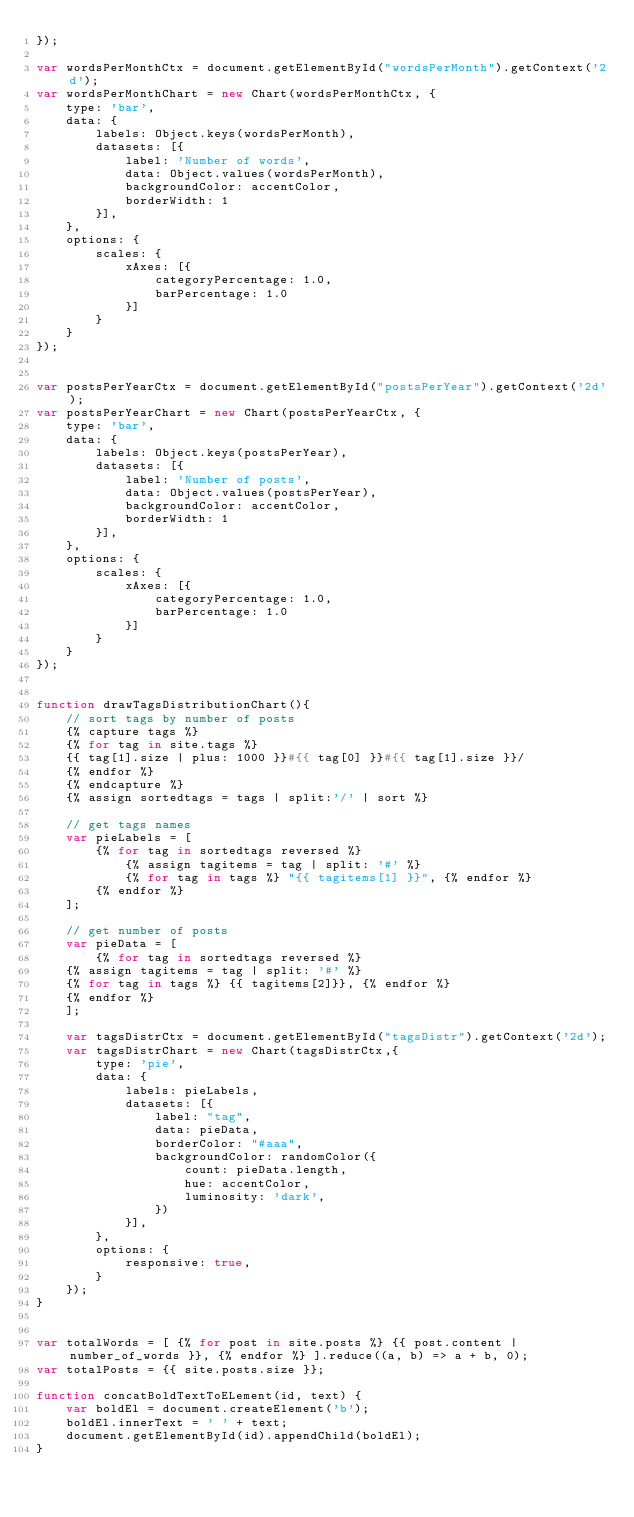<code> <loc_0><loc_0><loc_500><loc_500><_JavaScript_>});

var wordsPerMonthCtx = document.getElementById("wordsPerMonth").getContext('2d');
var wordsPerMonthChart = new Chart(wordsPerMonthCtx, {
    type: 'bar',
    data: {
        labels: Object.keys(wordsPerMonth),
        datasets: [{
            label: 'Number of words',
            data: Object.values(wordsPerMonth),
            backgroundColor: accentColor,
            borderWidth: 1
        }],
    },
    options: {
        scales: {
            xAxes: [{
                categoryPercentage: 1.0,
                barPercentage: 1.0
            }]
        }
    }
});


var postsPerYearCtx = document.getElementById("postsPerYear").getContext('2d');
var postsPerYearChart = new Chart(postsPerYearCtx, {
    type: 'bar',
    data: {
        labels: Object.keys(postsPerYear),
        datasets: [{
            label: 'Number of posts',
            data: Object.values(postsPerYear),
            backgroundColor: accentColor,
            borderWidth: 1
        }],
    },
    options: {
        scales: {
            xAxes: [{
                categoryPercentage: 1.0,
                barPercentage: 1.0
            }]
        }
    }
});


function drawTagsDistributionChart(){
    // sort tags by number of posts
    {% capture tags %}
    {% for tag in site.tags %}
    {{ tag[1].size | plus: 1000 }}#{{ tag[0] }}#{{ tag[1].size }}/
    {% endfor %}
    {% endcapture %}
    {% assign sortedtags = tags | split:'/' | sort %}

    // get tags names
    var pieLabels = [
        {% for tag in sortedtags reversed %}
            {% assign tagitems = tag | split: '#' %}
            {% for tag in tags %} "{{ tagitems[1] }}", {% endfor %}
        {% endfor %}
    ];

    // get number of posts
    var pieData = [
        {% for tag in sortedtags reversed %}
    {% assign tagitems = tag | split: '#' %}
    {% for tag in tags %} {{ tagitems[2]}}, {% endfor %}
    {% endfor %}
    ];

    var tagsDistrCtx = document.getElementById("tagsDistr").getContext('2d');
    var tagsDistrChart = new Chart(tagsDistrCtx,{
        type: 'pie',
        data: {
            labels: pieLabels,
            datasets: [{
                label: "tag",
                data: pieData,
                borderColor: "#aaa",
                backgroundColor: randomColor({
                    count: pieData.length,
                    hue: accentColor,
                    luminosity: 'dark',
                })
            }],
        },
        options: {
            responsive: true,
        }
    });
}


var totalWords = [ {% for post in site.posts %} {{ post.content | number_of_words }}, {% endfor %} ].reduce((a, b) => a + b, 0);
var totalPosts = {{ site.posts.size }};

function concatBoldTextToELement(id, text) {
    var boldEl = document.createElement('b');
    boldEl.innerText = ' ' + text;
    document.getElementById(id).appendChild(boldEl);
}
</code> 